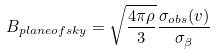<formula> <loc_0><loc_0><loc_500><loc_500>B _ { p l a n e o f s k y } = \sqrt { \frac { 4 \pi \rho } { 3 } } \frac { \sigma _ { o b s } ( v ) } { \sigma _ { \beta } }</formula> 